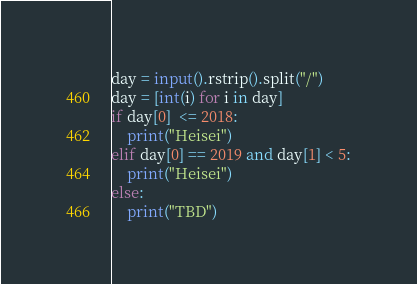Convert code to text. <code><loc_0><loc_0><loc_500><loc_500><_Python_>day = input().rstrip().split("/")
day = [int(i) for i in day]
if day[0]  <= 2018:
    print("Heisei")
elif day[0] == 2019 and day[1] < 5:
    print("Heisei")
else:
    print("TBD")</code> 